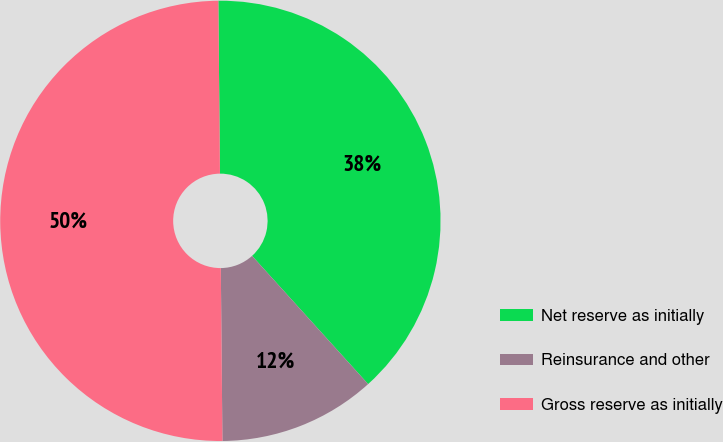Convert chart to OTSL. <chart><loc_0><loc_0><loc_500><loc_500><pie_chart><fcel>Net reserve as initially<fcel>Reinsurance and other<fcel>Gross reserve as initially<nl><fcel>38.44%<fcel>11.56%<fcel>50.0%<nl></chart> 